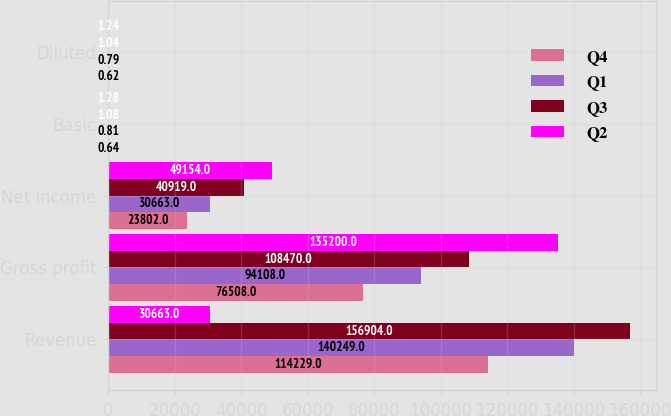Convert chart to OTSL. <chart><loc_0><loc_0><loc_500><loc_500><stacked_bar_chart><ecel><fcel>Revenue<fcel>Gross profit<fcel>Net income<fcel>Basic<fcel>Diluted<nl><fcel>Q4<fcel>114229<fcel>76508<fcel>23802<fcel>0.64<fcel>0.62<nl><fcel>Q1<fcel>140249<fcel>94108<fcel>30663<fcel>0.81<fcel>0.79<nl><fcel>Q3<fcel>156904<fcel>108470<fcel>40919<fcel>1.08<fcel>1.04<nl><fcel>Q2<fcel>30663<fcel>135200<fcel>49154<fcel>1.28<fcel>1.24<nl></chart> 